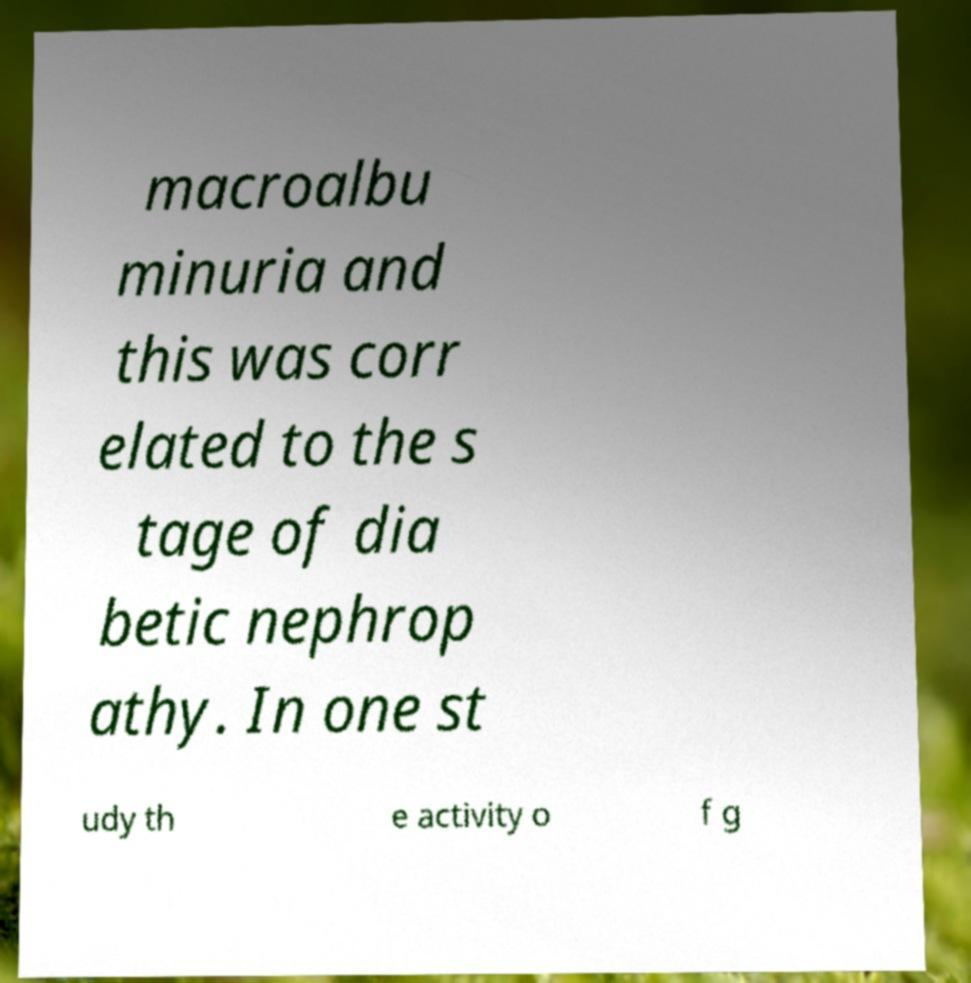Could you assist in decoding the text presented in this image and type it out clearly? macroalbu minuria and this was corr elated to the s tage of dia betic nephrop athy. In one st udy th e activity o f g 